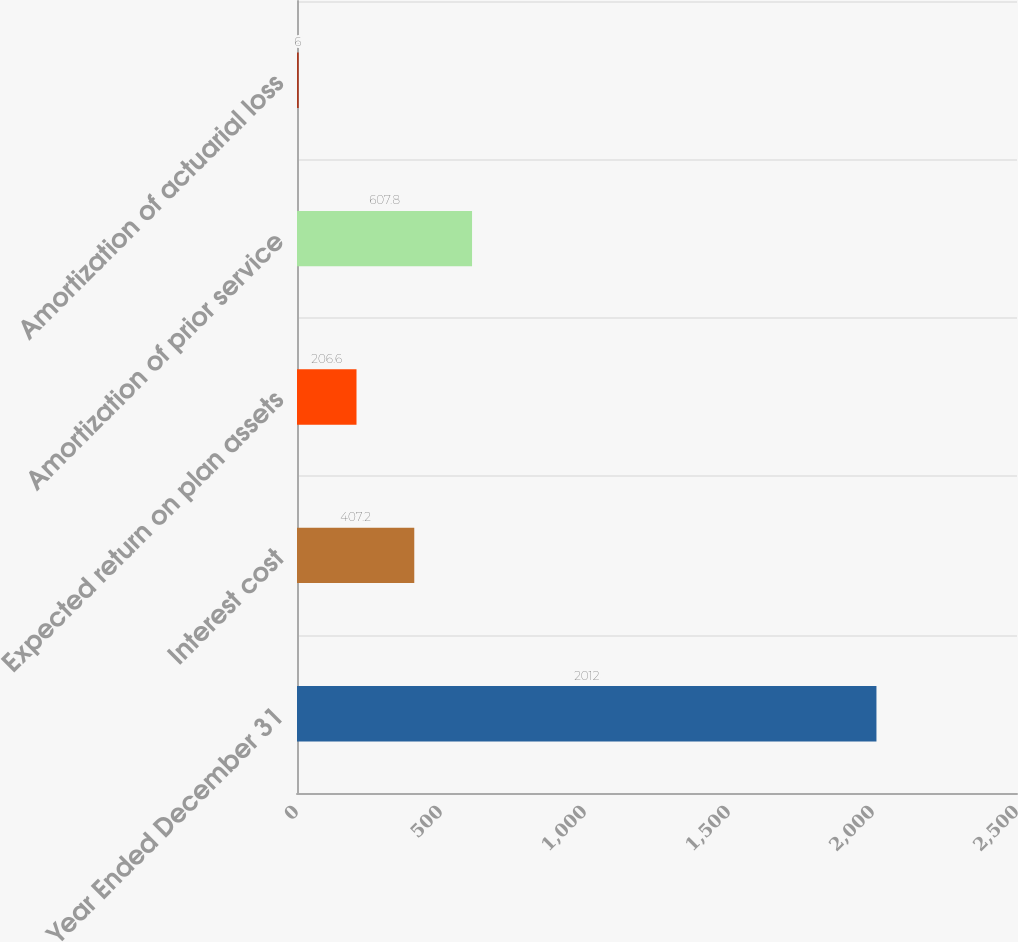<chart> <loc_0><loc_0><loc_500><loc_500><bar_chart><fcel>Year Ended December 31<fcel>Interest cost<fcel>Expected return on plan assets<fcel>Amortization of prior service<fcel>Amortization of actuarial loss<nl><fcel>2012<fcel>407.2<fcel>206.6<fcel>607.8<fcel>6<nl></chart> 